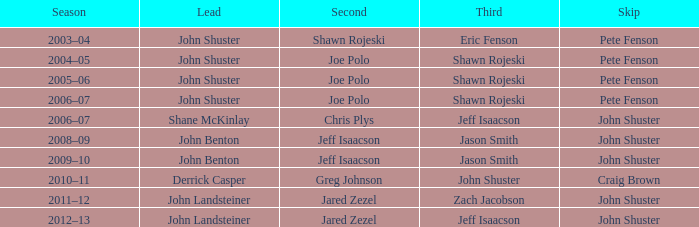Who was the lead with John Shuster as skip, Chris Plys in second, and Jeff Isaacson in third? Shane McKinlay. 